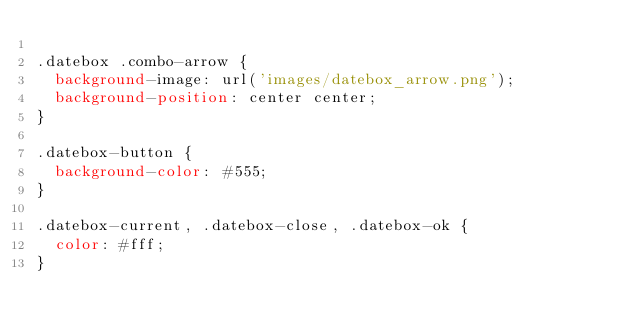<code> <loc_0><loc_0><loc_500><loc_500><_CSS_>
.datebox .combo-arrow {
	background-image: url('images/datebox_arrow.png');
	background-position: center center;
}

.datebox-button {
	background-color: #555;
}

.datebox-current, .datebox-close, .datebox-ok {
	color: #fff;
}</code> 